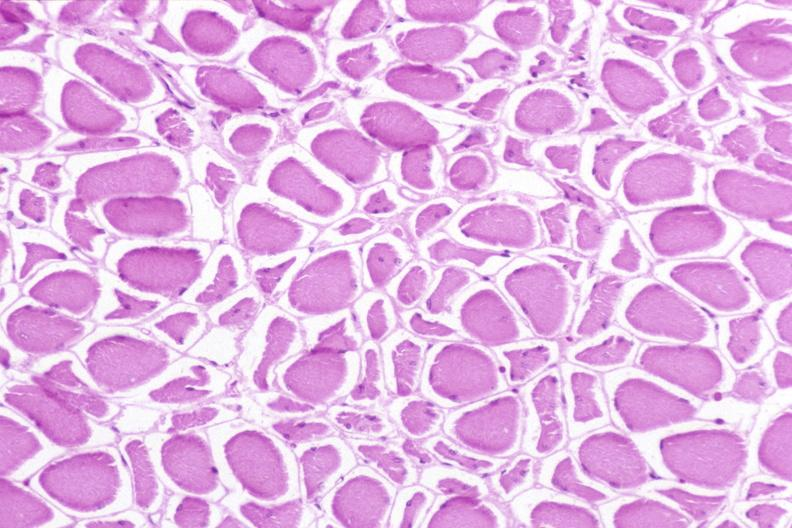s musculoskeletal present?
Answer the question using a single word or phrase. Yes 